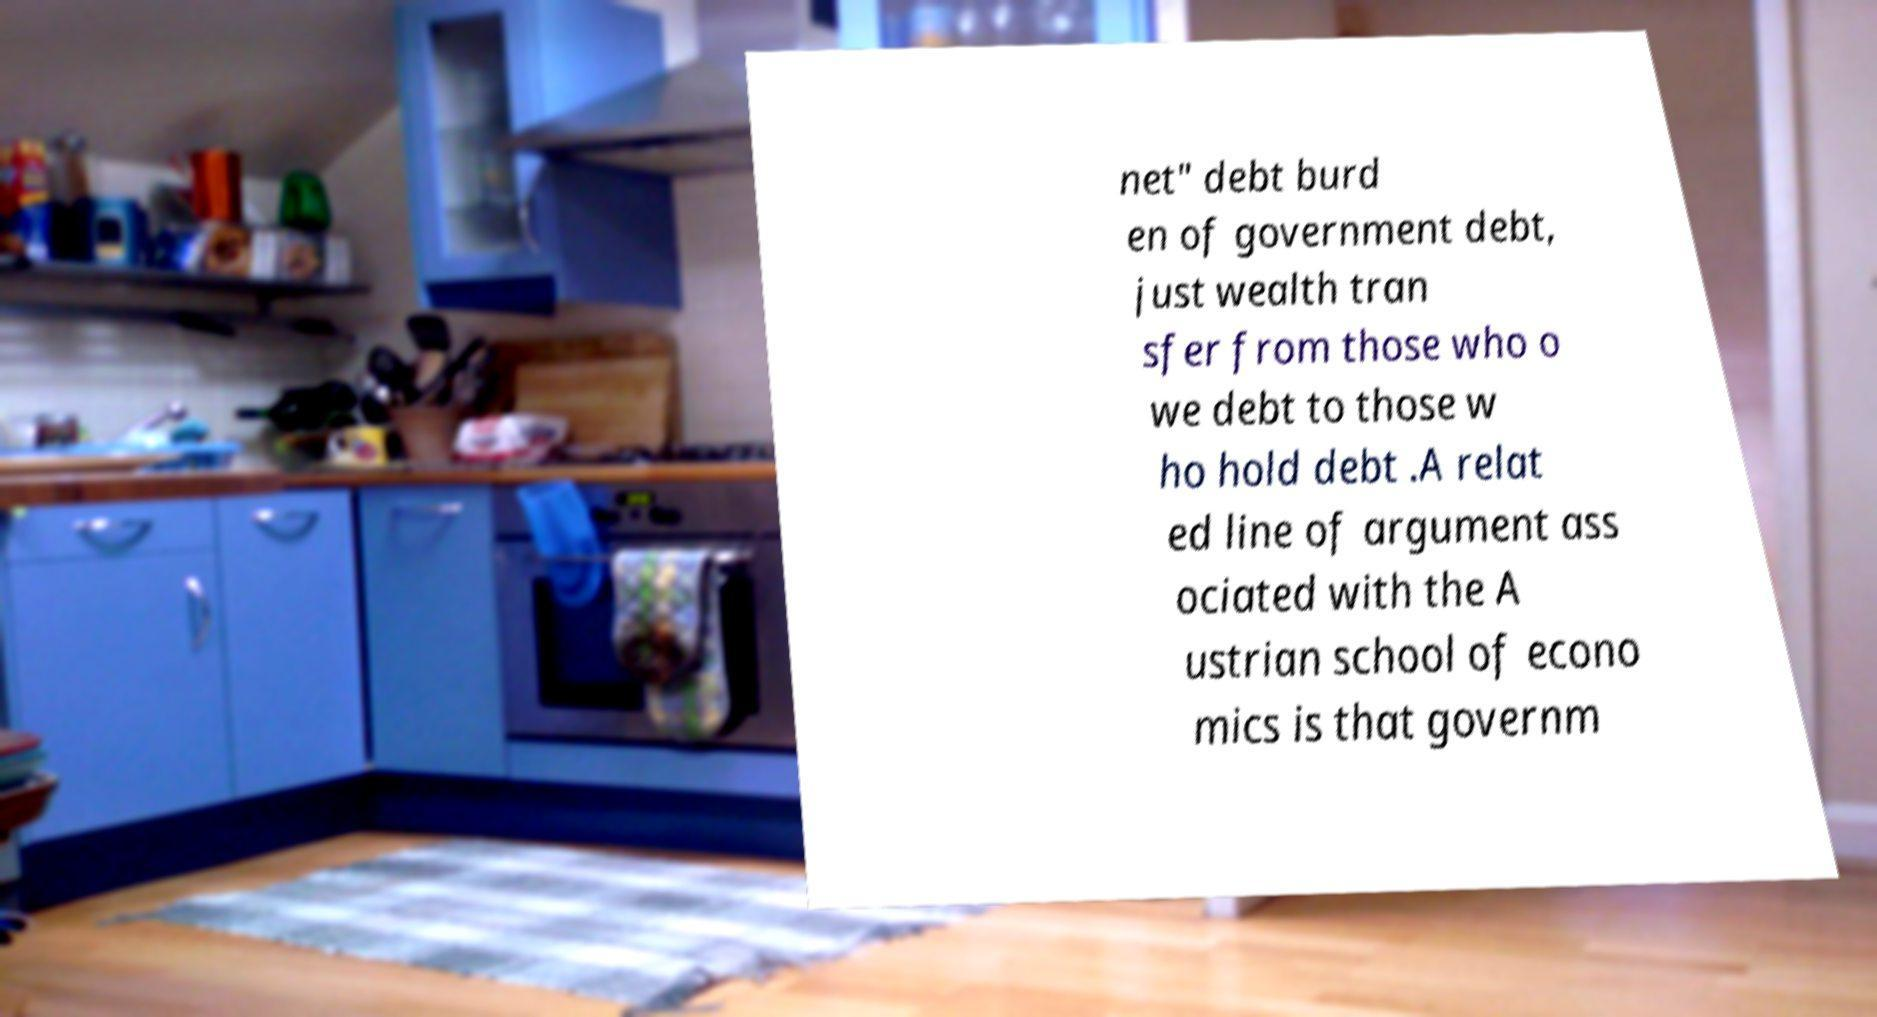Could you extract and type out the text from this image? net" debt burd en of government debt, just wealth tran sfer from those who o we debt to those w ho hold debt .A relat ed line of argument ass ociated with the A ustrian school of econo mics is that governm 